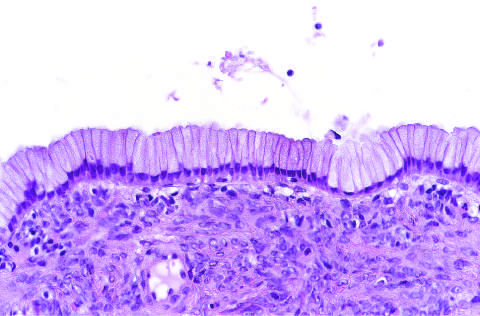what are lined by columnar mucinous epithelium, with a densely cellular ovarian stroma?
Answer the question using a single word or phrase. The cysts 